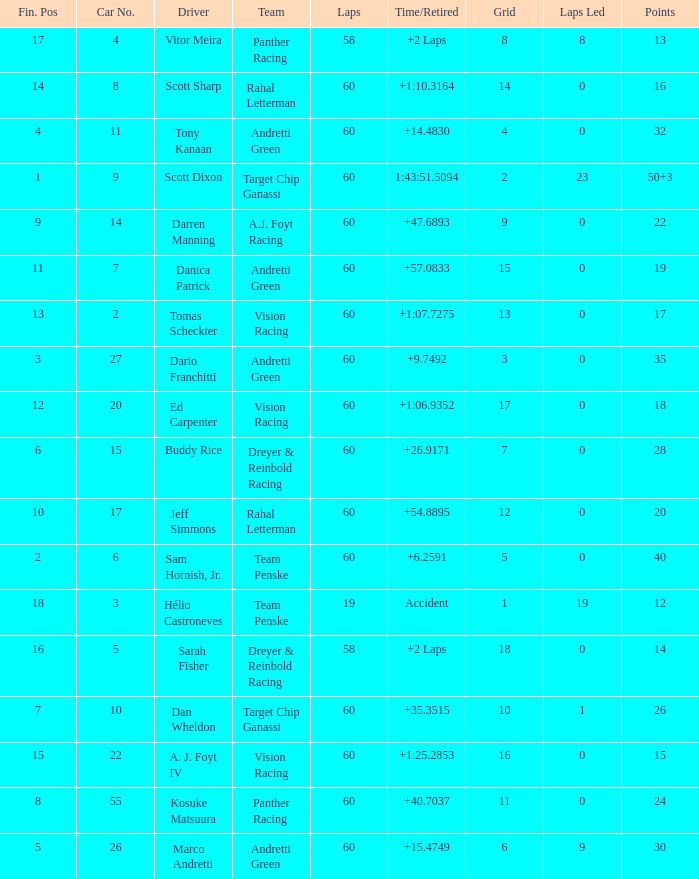Name the laps for 18 pointss 60.0. 